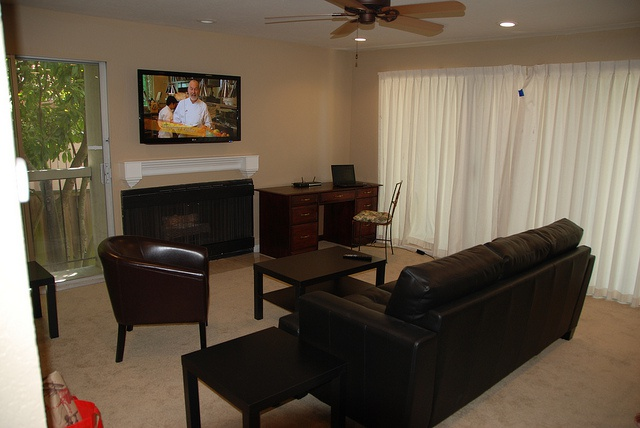Describe the objects in this image and their specific colors. I can see couch in black and darkgray tones, chair in black, gray, and maroon tones, tv in black, olive, maroon, and darkgray tones, chair in black, gray, and maroon tones, and chair in black, darkgreen, gray, and maroon tones in this image. 